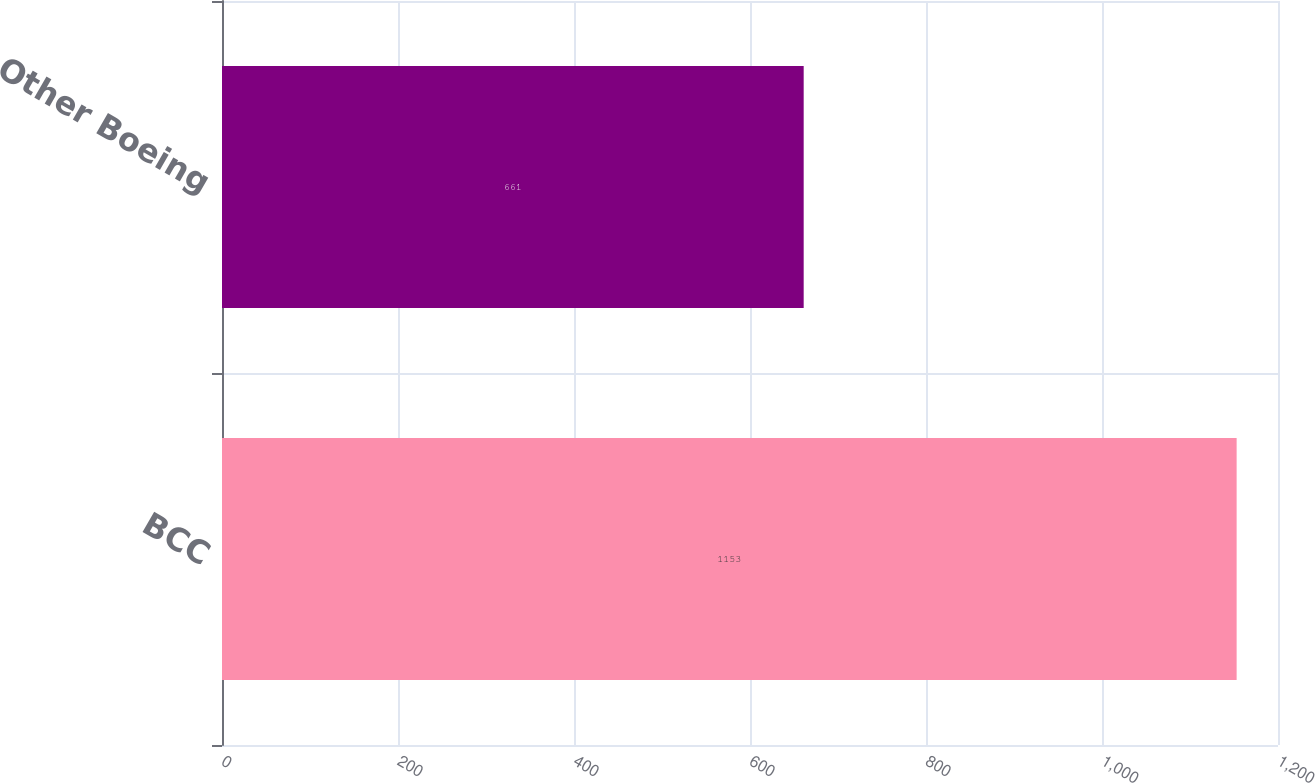<chart> <loc_0><loc_0><loc_500><loc_500><bar_chart><fcel>BCC<fcel>Other Boeing<nl><fcel>1153<fcel>661<nl></chart> 